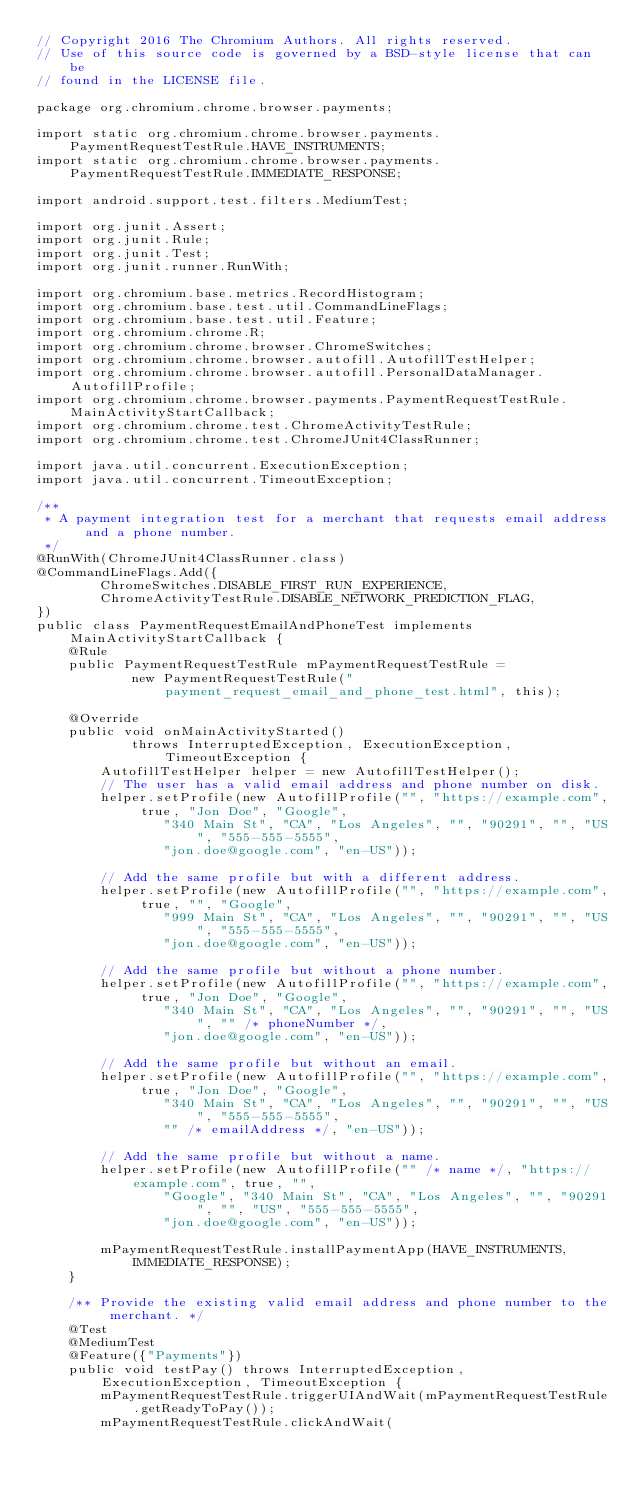Convert code to text. <code><loc_0><loc_0><loc_500><loc_500><_Java_>// Copyright 2016 The Chromium Authors. All rights reserved.
// Use of this source code is governed by a BSD-style license that can be
// found in the LICENSE file.

package org.chromium.chrome.browser.payments;

import static org.chromium.chrome.browser.payments.PaymentRequestTestRule.HAVE_INSTRUMENTS;
import static org.chromium.chrome.browser.payments.PaymentRequestTestRule.IMMEDIATE_RESPONSE;

import android.support.test.filters.MediumTest;

import org.junit.Assert;
import org.junit.Rule;
import org.junit.Test;
import org.junit.runner.RunWith;

import org.chromium.base.metrics.RecordHistogram;
import org.chromium.base.test.util.CommandLineFlags;
import org.chromium.base.test.util.Feature;
import org.chromium.chrome.R;
import org.chromium.chrome.browser.ChromeSwitches;
import org.chromium.chrome.browser.autofill.AutofillTestHelper;
import org.chromium.chrome.browser.autofill.PersonalDataManager.AutofillProfile;
import org.chromium.chrome.browser.payments.PaymentRequestTestRule.MainActivityStartCallback;
import org.chromium.chrome.test.ChromeActivityTestRule;
import org.chromium.chrome.test.ChromeJUnit4ClassRunner;

import java.util.concurrent.ExecutionException;
import java.util.concurrent.TimeoutException;

/**
 * A payment integration test for a merchant that requests email address and a phone number.
 */
@RunWith(ChromeJUnit4ClassRunner.class)
@CommandLineFlags.Add({
        ChromeSwitches.DISABLE_FIRST_RUN_EXPERIENCE,
        ChromeActivityTestRule.DISABLE_NETWORK_PREDICTION_FLAG,
})
public class PaymentRequestEmailAndPhoneTest implements MainActivityStartCallback {
    @Rule
    public PaymentRequestTestRule mPaymentRequestTestRule =
            new PaymentRequestTestRule("payment_request_email_and_phone_test.html", this);

    @Override
    public void onMainActivityStarted()
            throws InterruptedException, ExecutionException, TimeoutException {
        AutofillTestHelper helper = new AutofillTestHelper();
        // The user has a valid email address and phone number on disk.
        helper.setProfile(new AutofillProfile("", "https://example.com", true, "Jon Doe", "Google",
                "340 Main St", "CA", "Los Angeles", "", "90291", "", "US", "555-555-5555",
                "jon.doe@google.com", "en-US"));

        // Add the same profile but with a different address.
        helper.setProfile(new AutofillProfile("", "https://example.com", true, "", "Google",
                "999 Main St", "CA", "Los Angeles", "", "90291", "", "US", "555-555-5555",
                "jon.doe@google.com", "en-US"));

        // Add the same profile but without a phone number.
        helper.setProfile(new AutofillProfile("", "https://example.com", true, "Jon Doe", "Google",
                "340 Main St", "CA", "Los Angeles", "", "90291", "", "US", "" /* phoneNumber */,
                "jon.doe@google.com", "en-US"));

        // Add the same profile but without an email.
        helper.setProfile(new AutofillProfile("", "https://example.com", true, "Jon Doe", "Google",
                "340 Main St", "CA", "Los Angeles", "", "90291", "", "US", "555-555-5555",
                "" /* emailAddress */, "en-US"));

        // Add the same profile but without a name.
        helper.setProfile(new AutofillProfile("" /* name */, "https://example.com", true, "",
                "Google", "340 Main St", "CA", "Los Angeles", "", "90291", "", "US", "555-555-5555",
                "jon.doe@google.com", "en-US"));

        mPaymentRequestTestRule.installPaymentApp(HAVE_INSTRUMENTS, IMMEDIATE_RESPONSE);
    }

    /** Provide the existing valid email address and phone number to the merchant. */
    @Test
    @MediumTest
    @Feature({"Payments"})
    public void testPay() throws InterruptedException, ExecutionException, TimeoutException {
        mPaymentRequestTestRule.triggerUIAndWait(mPaymentRequestTestRule.getReadyToPay());
        mPaymentRequestTestRule.clickAndWait(</code> 